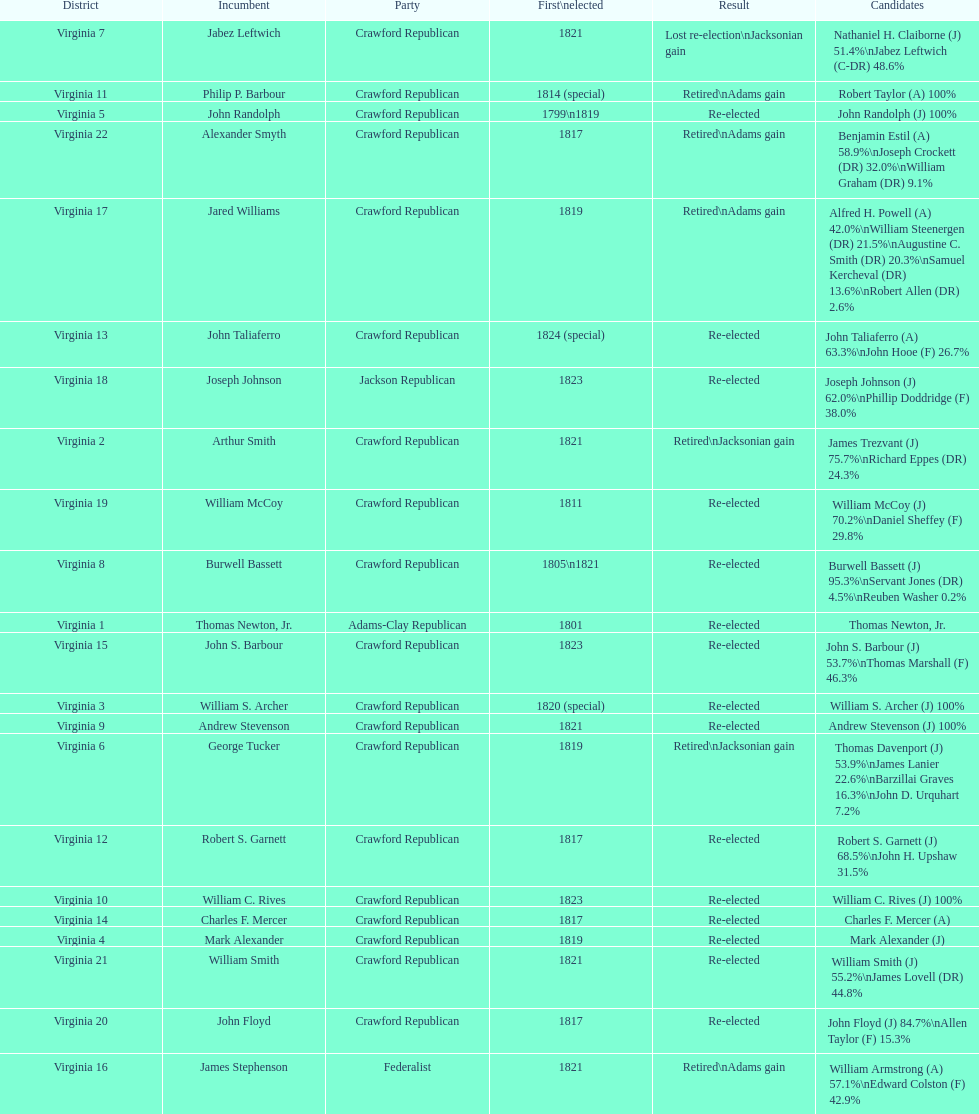How many candidates were there for virginia 17 district? 5. 